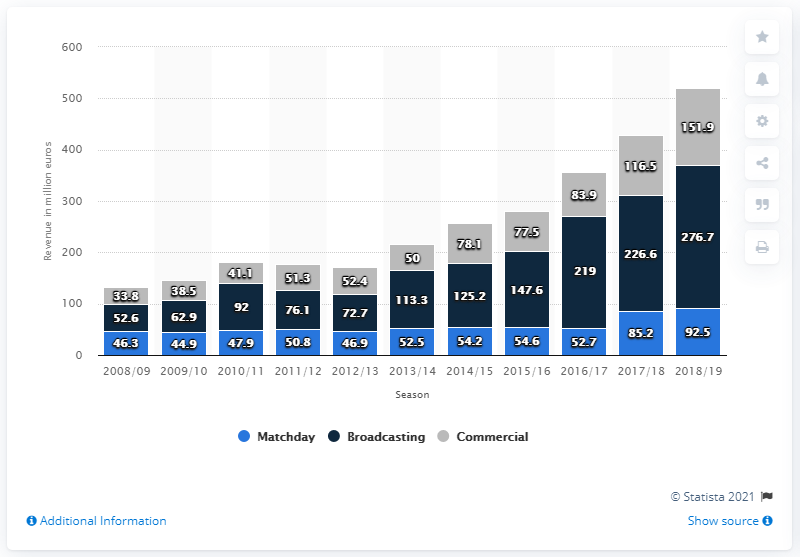Draw attention to some important aspects in this diagram. The revenue generated from Matchday, Broadcasting, and Commercial activities in the 2018/19 fiscal year was 521.1 million USD. The value of the highest blue bar is 92.5. 